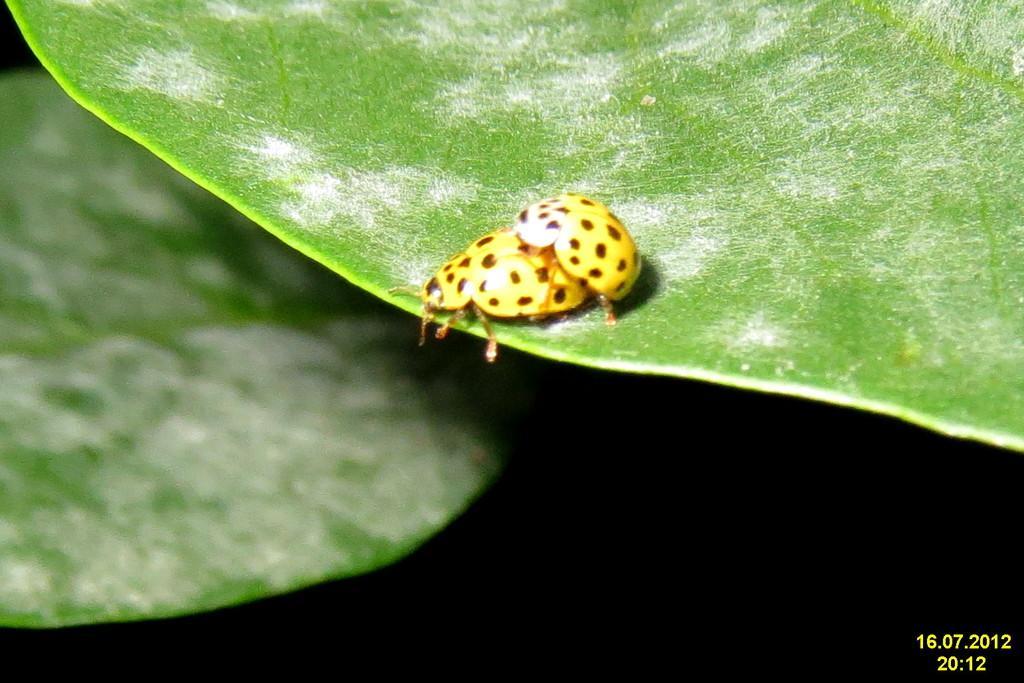Can you describe this image briefly? In this picture there is a bug in the center of the image on a leaf and there is another leaf in the background area of the image. 